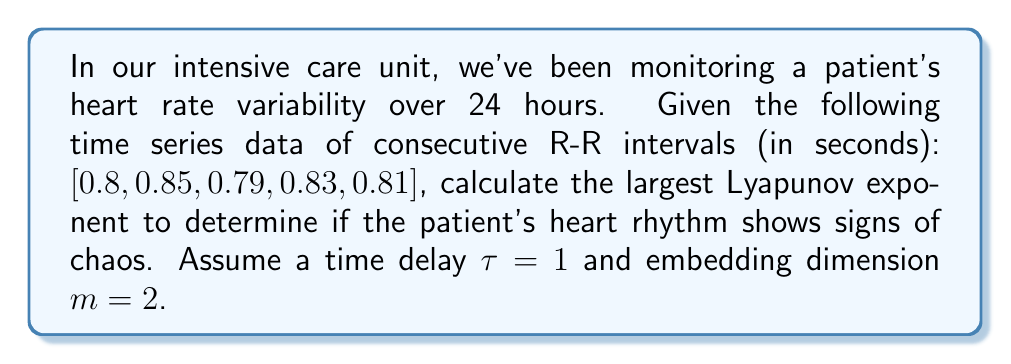Can you solve this math problem? To calculate the largest Lyapunov exponent for this time series:

1. Construct the phase space using time delay embedding:
   $$X_1 = (0.8, 0.85), X_2 = (0.85, 0.79), X_3 = (0.79, 0.83), X_4 = (0.83, 0.81)$$

2. For each point, find its nearest neighbor (excluding adjacent points):
   $X_1$ closest to $X_4$, $X_2$ closest to $X_4$, $X_3$ closest to $X_1$

3. Calculate the initial separation $d_0$ for each pair:
   $$d_0(1) = \sqrt{(0.8-0.83)^2 + (0.85-0.81)^2} = 0.05$$
   $$d_0(2) = \sqrt{(0.85-0.83)^2 + (0.79-0.81)^2} = 0.0283$$
   $$d_0(3) = \sqrt{(0.79-0.8)^2 + (0.83-0.85)^2} = 0.0224$$

4. Evolve each pair one time step and calculate new separations $d_1$:
   $$d_1(1) = \sqrt{(0.85-0.81)^2 + (0.79-0.85)^2} = 0.0721$$
   $$d_1(2) = \sqrt{(0.79-0.81)^2 + (0.83-0.85)^2} = 0.0283$$
   $$d_1(3) = \sqrt{(0.83-0.85)^2 + (0.81-0.79)^2} = 0.0283$$

5. Calculate the Lyapunov exponent for each pair:
   $$\lambda_1 = \frac{1}{\Delta t} \ln\frac{d_1(1)}{d_0(1)} = \frac{1}{1} \ln\frac{0.0721}{0.05} = 0.3677$$
   $$\lambda_2 = \frac{1}{\Delta t} \ln\frac{d_1(2)}{d_0(2)} = \frac{1}{1} \ln\frac{0.0283}{0.0283} = 0$$
   $$\lambda_3 = \frac{1}{\Delta t} \ln\frac{d_1(3)}{d_0(3)} = \frac{1}{1} \ln\frac{0.0283}{0.0224} = 0.2342$$

6. The largest Lyapunov exponent is the average of these values:
   $$\lambda_{max} = \frac{\lambda_1 + \lambda_2 + \lambda_3}{3} = \frac{0.3677 + 0 + 0.2342}{3} = 0.2006$$
Answer: $\lambda_{max} = 0.2006$ 